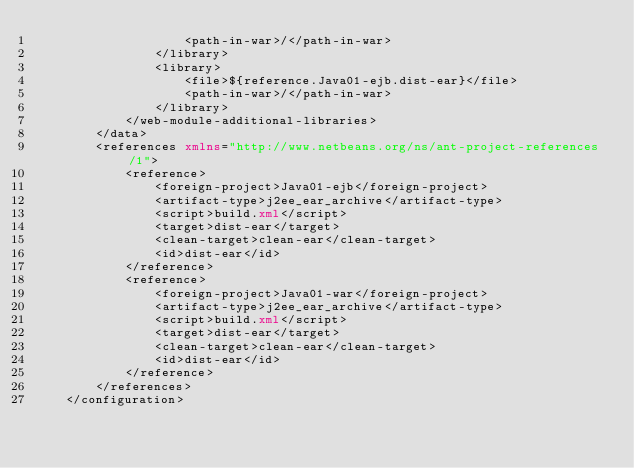<code> <loc_0><loc_0><loc_500><loc_500><_XML_>                    <path-in-war>/</path-in-war>
                </library>
                <library>
                    <file>${reference.Java01-ejb.dist-ear}</file>
                    <path-in-war>/</path-in-war>
                </library>
            </web-module-additional-libraries>
        </data>
        <references xmlns="http://www.netbeans.org/ns/ant-project-references/1">
            <reference>
                <foreign-project>Java01-ejb</foreign-project>
                <artifact-type>j2ee_ear_archive</artifact-type>
                <script>build.xml</script>
                <target>dist-ear</target>
                <clean-target>clean-ear</clean-target>
                <id>dist-ear</id>
            </reference>
            <reference>
                <foreign-project>Java01-war</foreign-project>
                <artifact-type>j2ee_ear_archive</artifact-type>
                <script>build.xml</script>
                <target>dist-ear</target>
                <clean-target>clean-ear</clean-target>
                <id>dist-ear</id>
            </reference>
        </references>
    </configuration></code> 